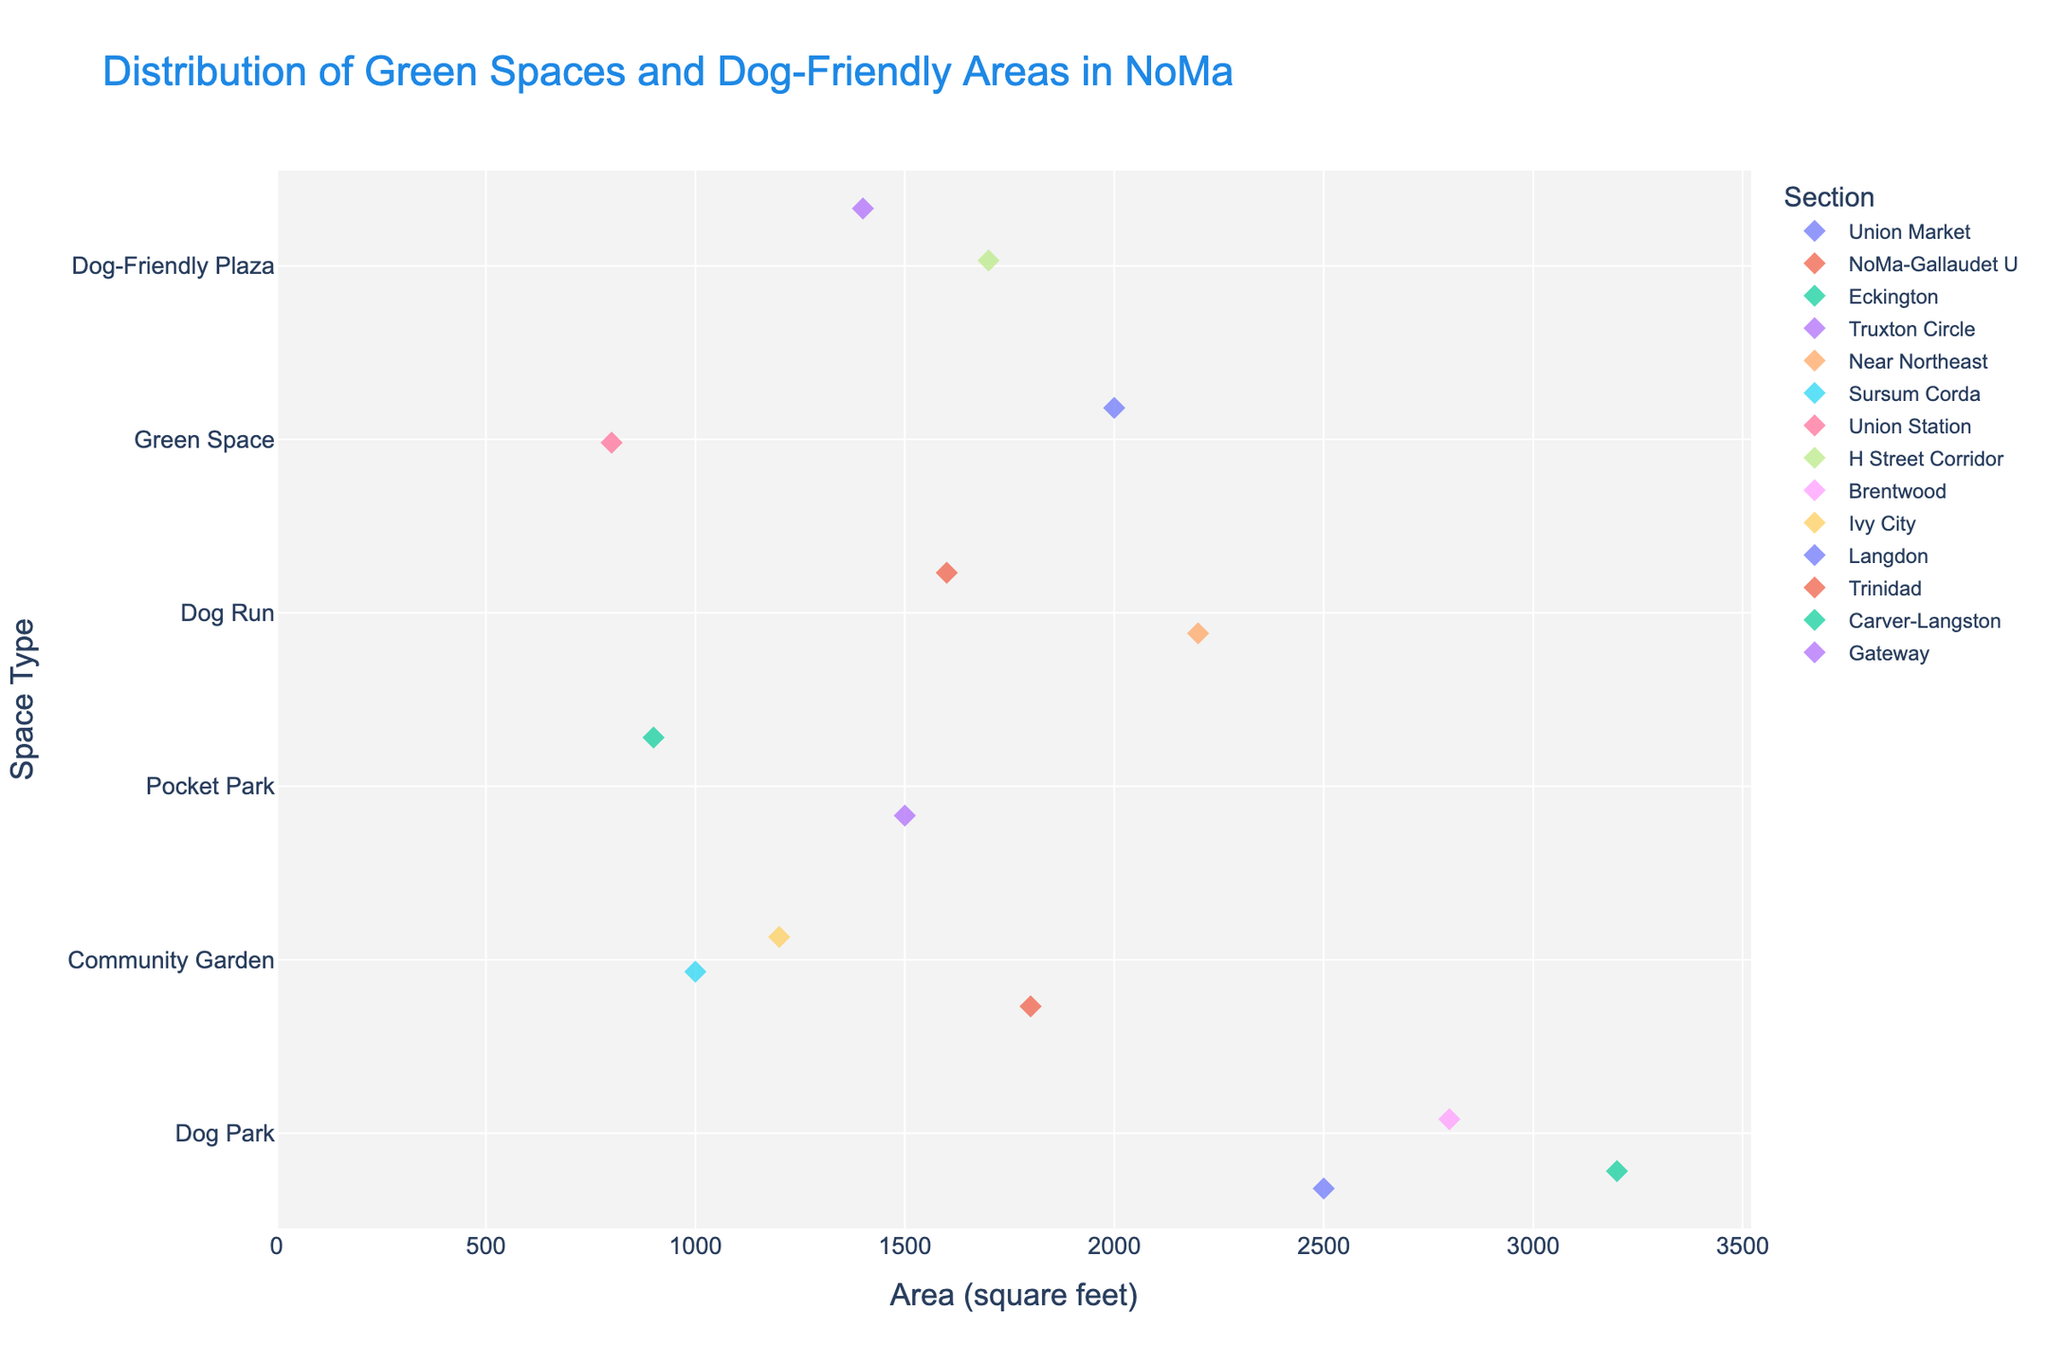Which section has the largest dog park? Look for the largest 'Dog Park' data point in the figure. The section with the largest 'Dog Park' is represented by the highest x value in the Dog Park row.
Answer: Eckington What type of green space is the smallest in area? Identify the data point with the smallest x value (area) on the y-axis for different space types.
Answer: Pocket Park Which sections have Community Gardens and how large are they? Locate the 'Community Garden' on the y-axis and check the associated sections and their x values (area). The sections and their areas are identified by the data points marked along this row.
Answer: NoMa-Gallaudet U (1800 sq ft), Sursum Corda (1000 sq ft), Ivy City (1200 sq ft) How much total area is dedicated to dog parks across all sections? Add the areas of all data points on the Dog Park row. The points represent Brentwood (2800 sq ft), Union Market (2500 sq ft), and Eckington (3200 sq ft). Summing them: 2800 + 2500 + 3200
Answer: 8500 sq ft Which space type has the most varied size of areas? Look across the rows to identify the space type with the widest range of x values (areas).
Answer: Dog Parks Which section has the smallest green space? Find the smallest marker on the x-axis and identify the corresponding section on the y-axis.
Answer: Union Station (800 sq ft) Is there any section with more than one type of space? Review the sections on the y-axis and note which sections appear more than once with different space types.
Answer: No Compare the area of the Dog-Friendly Plaza in the H Street Corridor to the one in Gateway. Which is larger and by how much? Identify the x values (areas) for 'Dog-Friendly Plaza' in 'H Street Corridor' and 'Gateway'. Calculate the difference: 1700 - 1400
Answer: H Street Corridor is larger by 300 sq ft Which type of space is the most common? Count the number of data points for each type on the y-axis to see which has the most entries.
Answer: Dog Park What is the average size of Dog Runs? Locate 'Dog Run' on the y-axis and check the x values (areas) of the corresponding sections. Sum the areas and divide by the number of points: (2200 + 1600) / 2
Answer: 1900 sq ft 